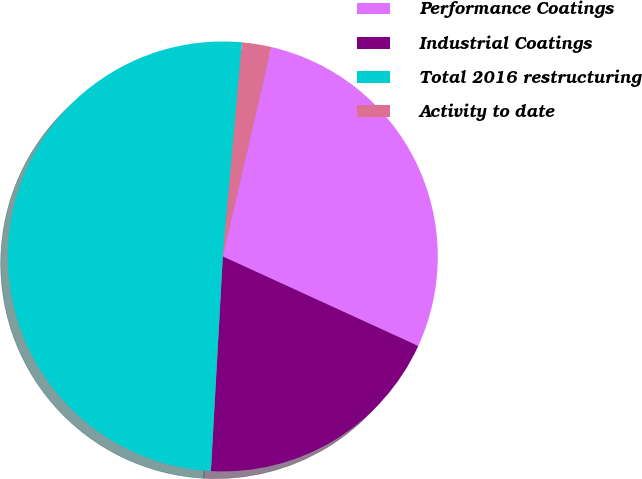Convert chart. <chart><loc_0><loc_0><loc_500><loc_500><pie_chart><fcel>Performance Coatings<fcel>Industrial Coatings<fcel>Total 2016 restructuring<fcel>Activity to date<nl><fcel>28.21%<fcel>19.05%<fcel>50.55%<fcel>2.2%<nl></chart> 